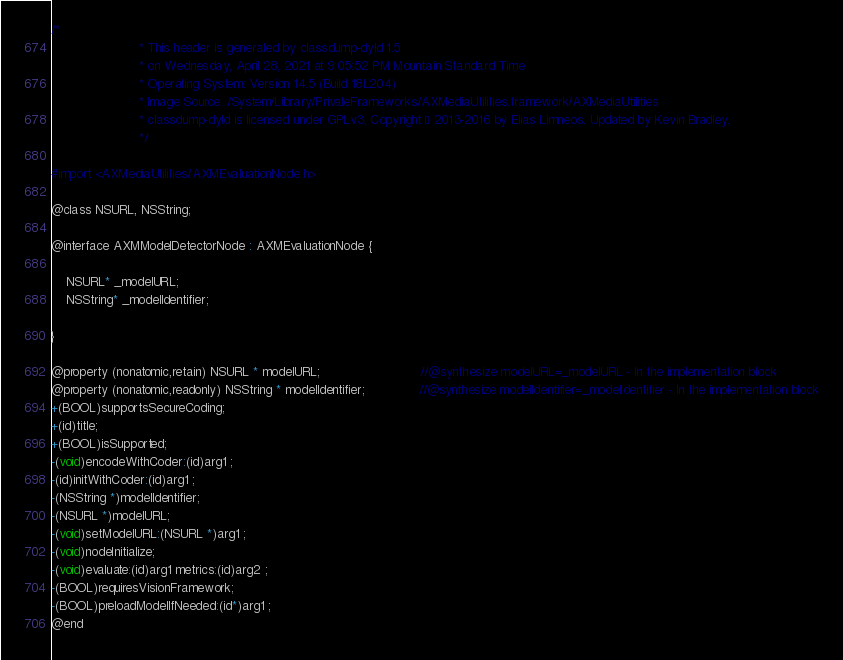<code> <loc_0><loc_0><loc_500><loc_500><_C_>/*
                       * This header is generated by classdump-dyld 1.5
                       * on Wednesday, April 28, 2021 at 9:05:52 PM Mountain Standard Time
                       * Operating System: Version 14.5 (Build 18L204)
                       * Image Source: /System/Library/PrivateFrameworks/AXMediaUtilities.framework/AXMediaUtilities
                       * classdump-dyld is licensed under GPLv3, Copyright © 2013-2016 by Elias Limneos. Updated by Kevin Bradley.
                       */

#import <AXMediaUtilities/AXMEvaluationNode.h>

@class NSURL, NSString;

@interface AXMModelDetectorNode : AXMEvaluationNode {

	NSURL* _modelURL;
	NSString* _modelIdentifier;

}

@property (nonatomic,retain) NSURL * modelURL;                          //@synthesize modelURL=_modelURL - In the implementation block
@property (nonatomic,readonly) NSString * modelIdentifier;              //@synthesize modelIdentifier=_modelIdentifier - In the implementation block
+(BOOL)supportsSecureCoding;
+(id)title;
+(BOOL)isSupported;
-(void)encodeWithCoder:(id)arg1 ;
-(id)initWithCoder:(id)arg1 ;
-(NSString *)modelIdentifier;
-(NSURL *)modelURL;
-(void)setModelURL:(NSURL *)arg1 ;
-(void)nodeInitialize;
-(void)evaluate:(id)arg1 metrics:(id)arg2 ;
-(BOOL)requiresVisionFramework;
-(BOOL)preloadModelIfNeeded:(id*)arg1 ;
@end

</code> 